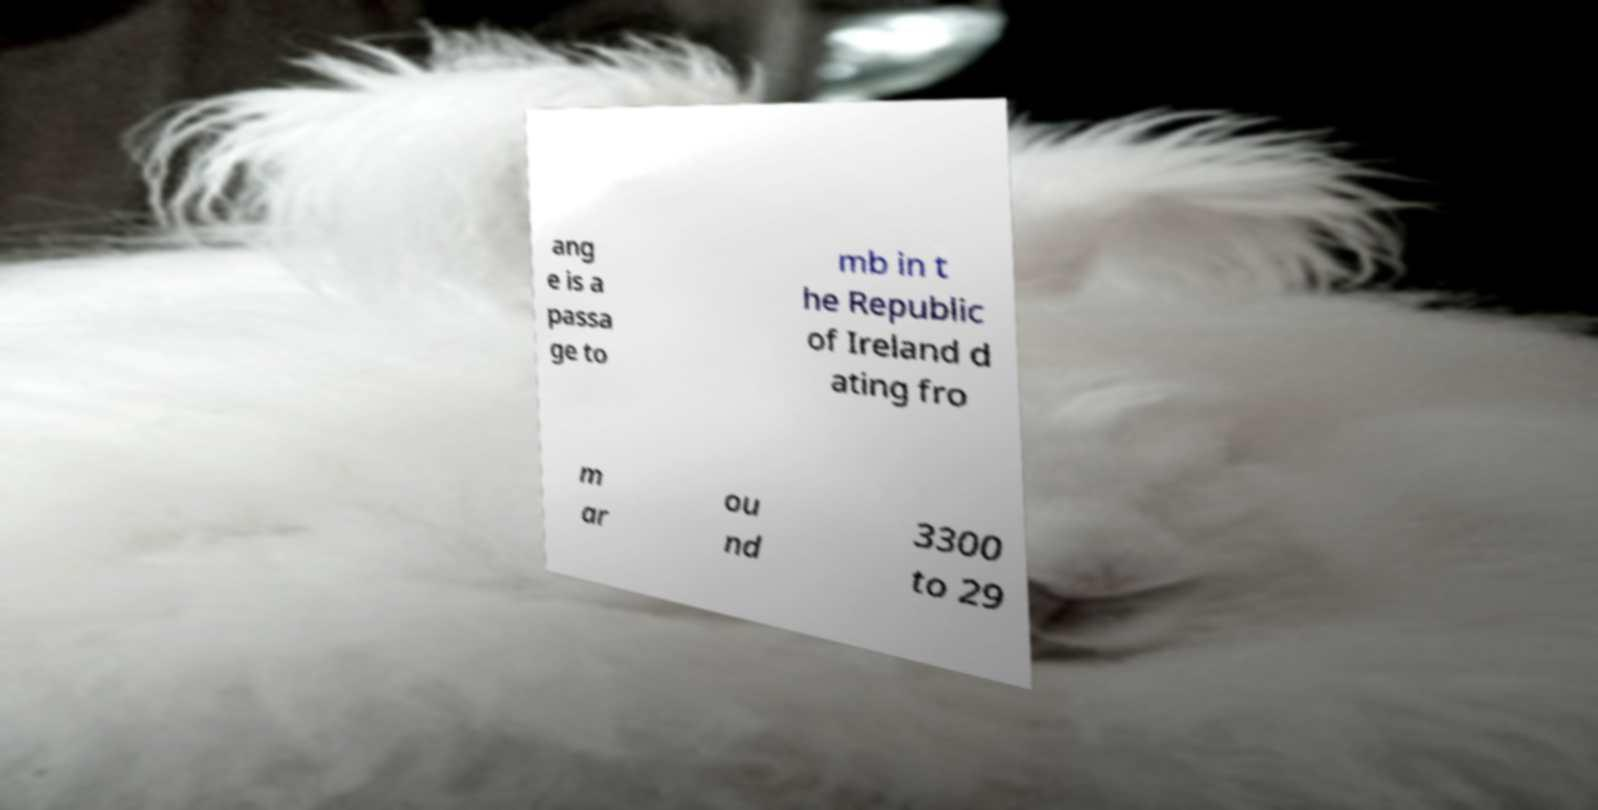Please read and relay the text visible in this image. What does it say? ang e is a passa ge to mb in t he Republic of Ireland d ating fro m ar ou nd 3300 to 29 